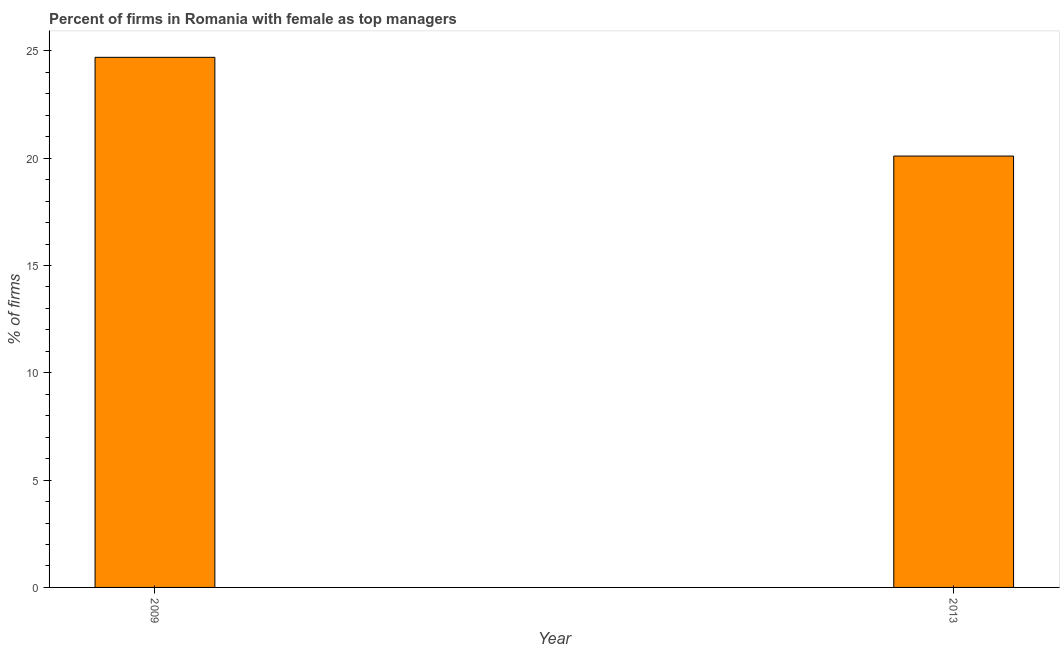Does the graph contain grids?
Your response must be concise. No. What is the title of the graph?
Keep it short and to the point. Percent of firms in Romania with female as top managers. What is the label or title of the X-axis?
Keep it short and to the point. Year. What is the label or title of the Y-axis?
Give a very brief answer. % of firms. What is the percentage of firms with female as top manager in 2013?
Offer a terse response. 20.1. Across all years, what is the maximum percentage of firms with female as top manager?
Offer a very short reply. 24.7. Across all years, what is the minimum percentage of firms with female as top manager?
Your answer should be compact. 20.1. What is the sum of the percentage of firms with female as top manager?
Provide a short and direct response. 44.8. What is the difference between the percentage of firms with female as top manager in 2009 and 2013?
Ensure brevity in your answer.  4.6. What is the average percentage of firms with female as top manager per year?
Give a very brief answer. 22.4. What is the median percentage of firms with female as top manager?
Give a very brief answer. 22.4. In how many years, is the percentage of firms with female as top manager greater than 14 %?
Give a very brief answer. 2. Do a majority of the years between 2009 and 2013 (inclusive) have percentage of firms with female as top manager greater than 24 %?
Ensure brevity in your answer.  No. What is the ratio of the percentage of firms with female as top manager in 2009 to that in 2013?
Make the answer very short. 1.23. Is the percentage of firms with female as top manager in 2009 less than that in 2013?
Your answer should be compact. No. How many bars are there?
Make the answer very short. 2. Are the values on the major ticks of Y-axis written in scientific E-notation?
Your response must be concise. No. What is the % of firms of 2009?
Provide a succinct answer. 24.7. What is the % of firms of 2013?
Make the answer very short. 20.1. What is the difference between the % of firms in 2009 and 2013?
Your answer should be compact. 4.6. What is the ratio of the % of firms in 2009 to that in 2013?
Offer a very short reply. 1.23. 